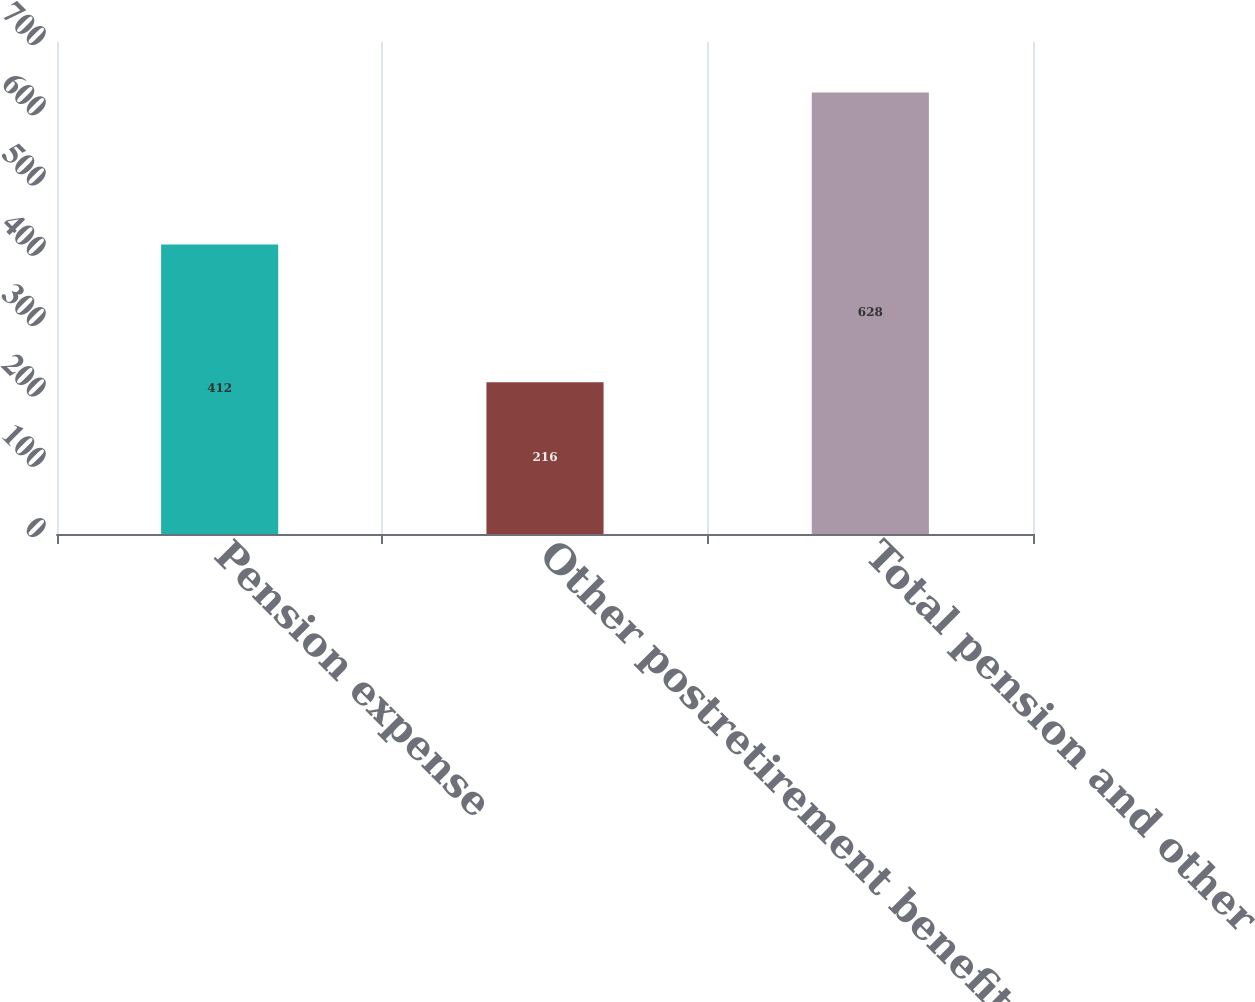<chart> <loc_0><loc_0><loc_500><loc_500><bar_chart><fcel>Pension expense<fcel>Other postretirement benefits<fcel>Total pension and other<nl><fcel>412<fcel>216<fcel>628<nl></chart> 